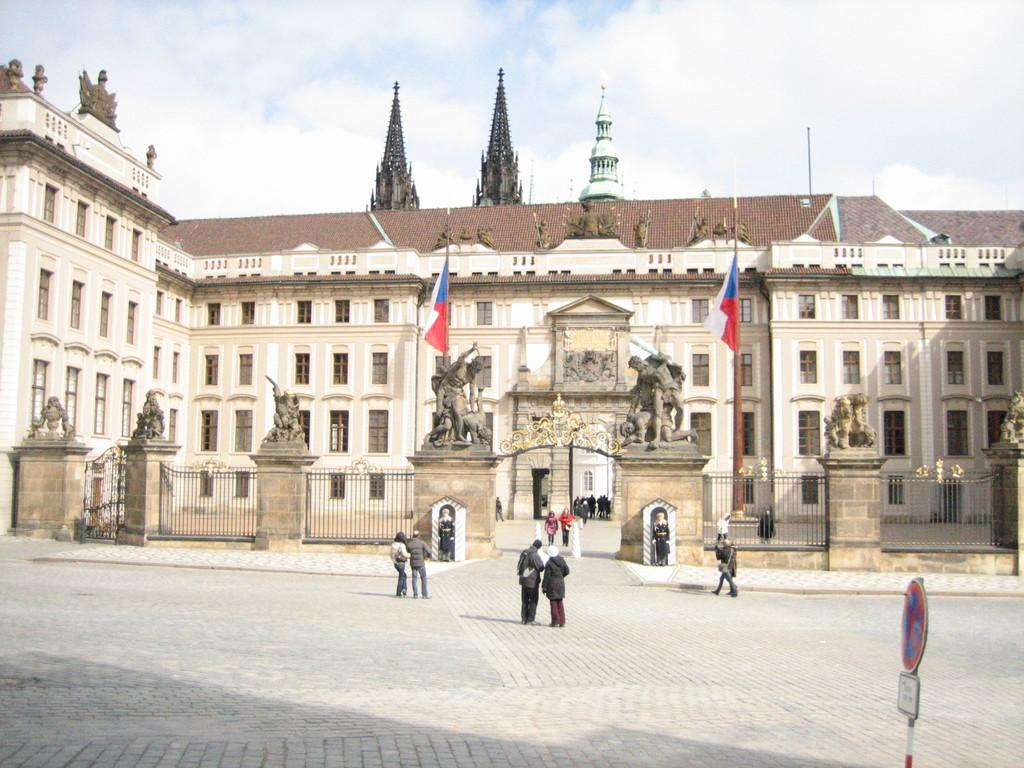What is the main structure visible in the image? There is a building in the image. What activity is taking place in front of the building? There are people walking in front of the building. Is there any additional information provided on the building? Yes, there is a sign board in the image. How many cows can be seen grazing on the farm in the image? There is no farm or cows present in the image; it features a building with people walking and a sign board. 